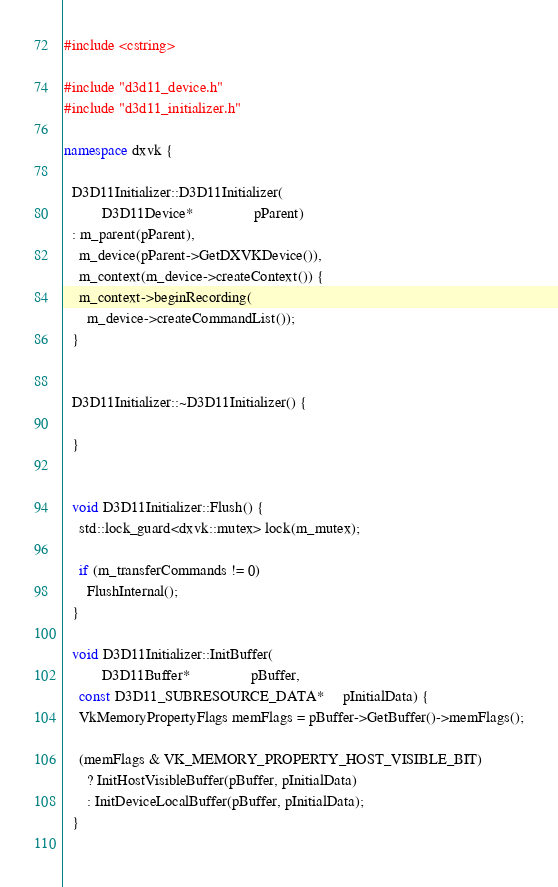Convert code to text. <code><loc_0><loc_0><loc_500><loc_500><_C++_>#include <cstring>

#include "d3d11_device.h"
#include "d3d11_initializer.h"

namespace dxvk {

  D3D11Initializer::D3D11Initializer(
          D3D11Device*                pParent)
  : m_parent(pParent),
    m_device(pParent->GetDXVKDevice()),
    m_context(m_device->createContext()) {
    m_context->beginRecording(
      m_device->createCommandList());
  }

  
  D3D11Initializer::~D3D11Initializer() {

  }


  void D3D11Initializer::Flush() {
    std::lock_guard<dxvk::mutex> lock(m_mutex);

    if (m_transferCommands != 0)
      FlushInternal();
  }

  void D3D11Initializer::InitBuffer(
          D3D11Buffer*                pBuffer,
    const D3D11_SUBRESOURCE_DATA*     pInitialData) {
    VkMemoryPropertyFlags memFlags = pBuffer->GetBuffer()->memFlags();

    (memFlags & VK_MEMORY_PROPERTY_HOST_VISIBLE_BIT)
      ? InitHostVisibleBuffer(pBuffer, pInitialData)
      : InitDeviceLocalBuffer(pBuffer, pInitialData);
  }
  
</code> 